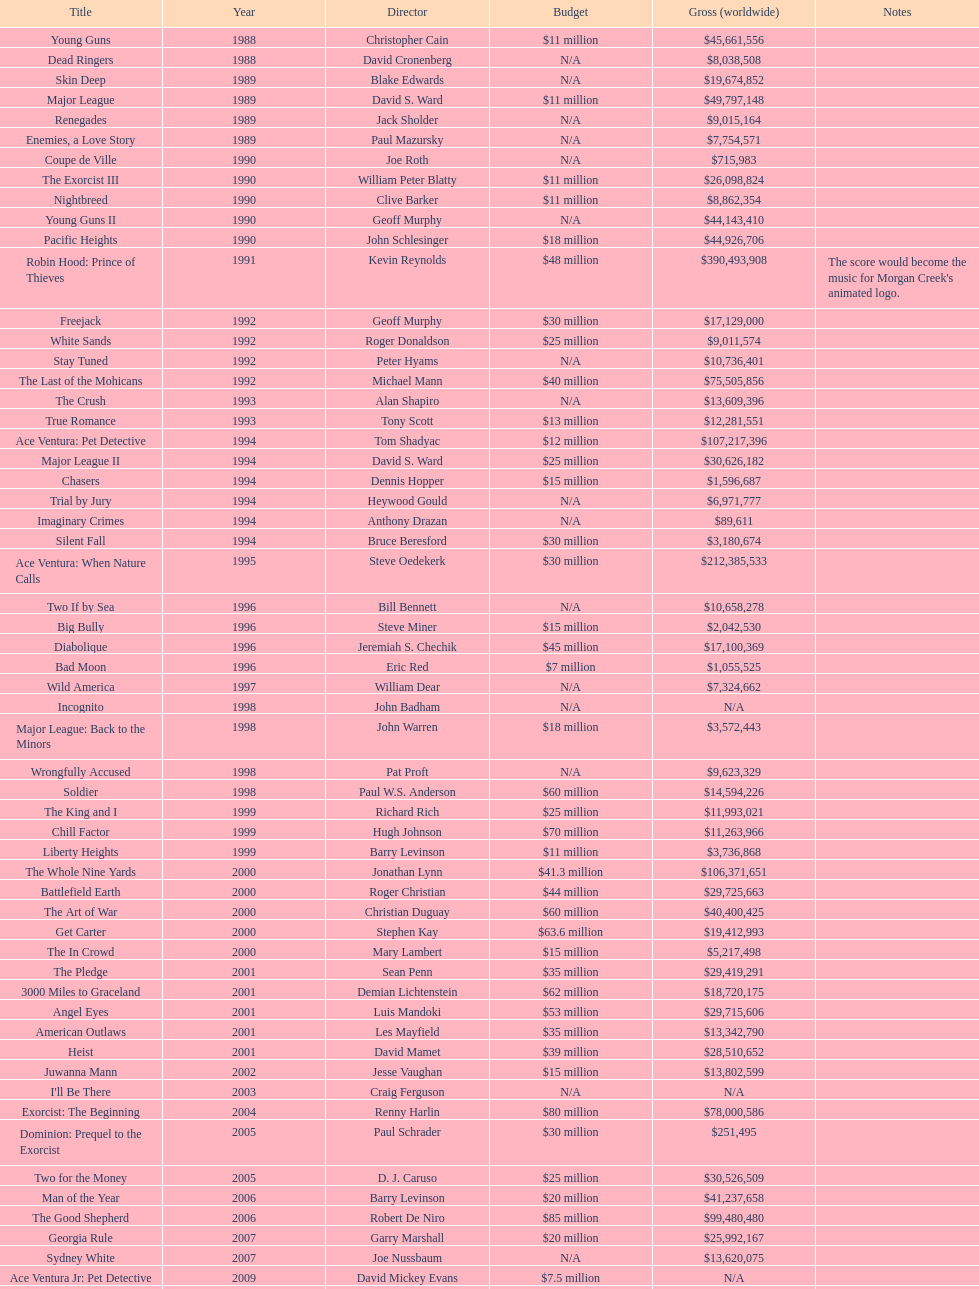For morgan creek productions, which film earned the most globally? Robin Hood: Prince of Thieves. 